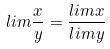<formula> <loc_0><loc_0><loc_500><loc_500>l i m \frac { x } { y } = \frac { l i m x } { l i m y }</formula> 